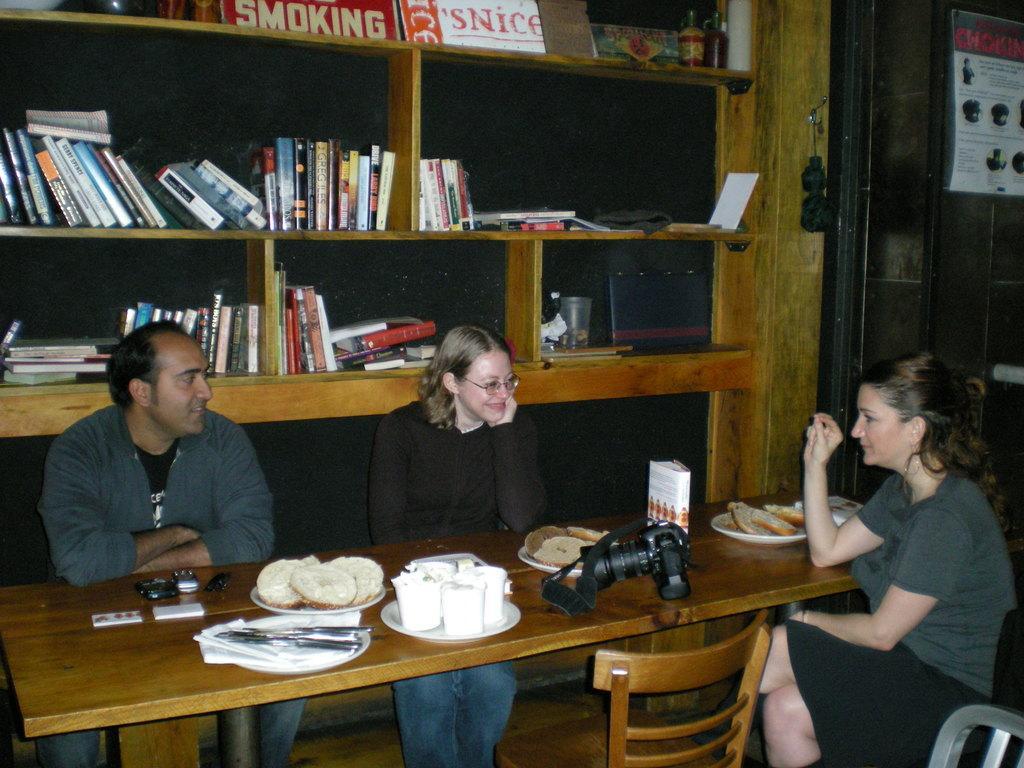In one or two sentences, can you explain what this image depicts? In this picture we can see three persons are sitting on the chairs. This is table. On the table there is a camera, some food, and plates. And on the background there is a rack. And there are some books in that. 